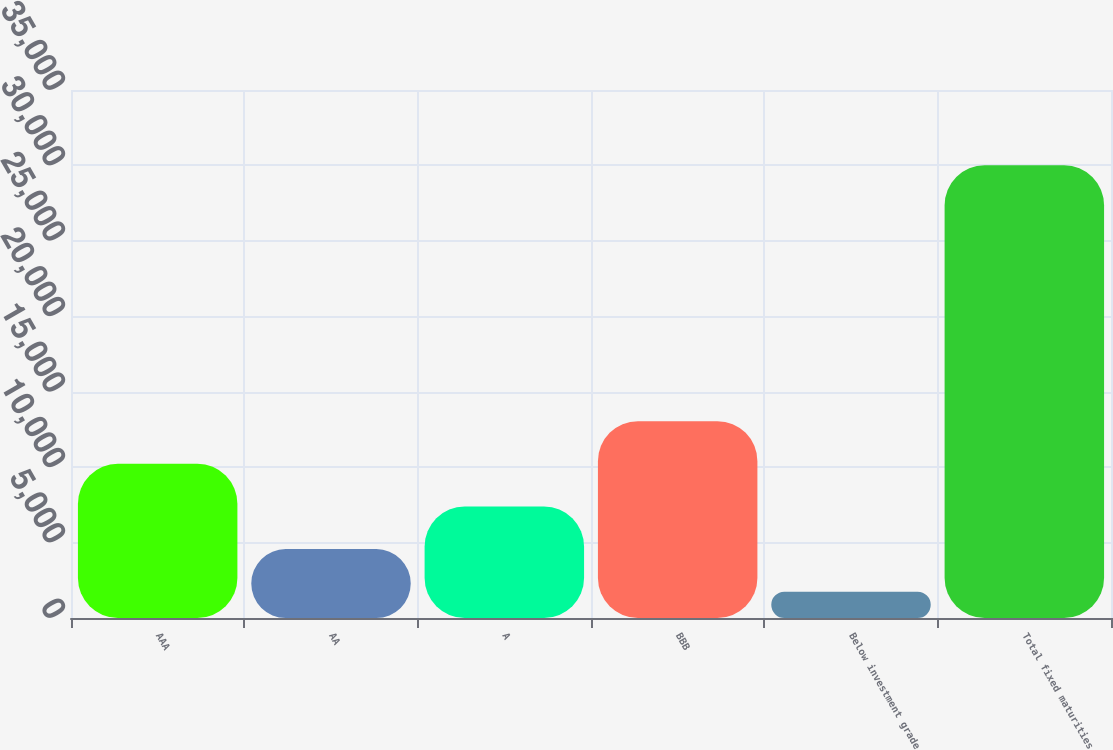Convert chart. <chart><loc_0><loc_0><loc_500><loc_500><bar_chart><fcel>AAA<fcel>AA<fcel>A<fcel>BBB<fcel>Below investment grade<fcel>Total fixed maturities<nl><fcel>10221.4<fcel>4567.8<fcel>7394.6<fcel>13048.2<fcel>1741<fcel>30009<nl></chart> 